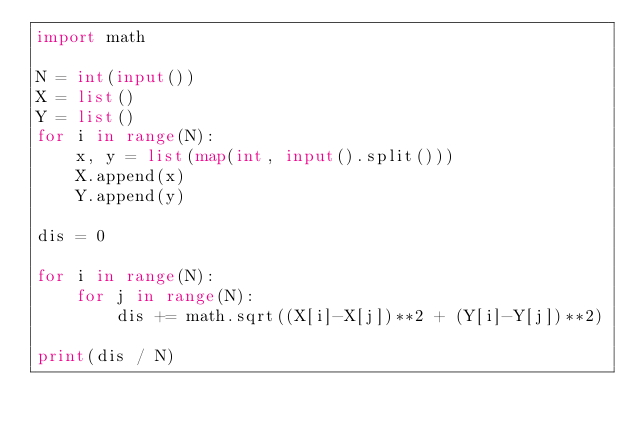Convert code to text. <code><loc_0><loc_0><loc_500><loc_500><_Python_>import math

N = int(input())
X = list()
Y = list()
for i in range(N):
    x, y = list(map(int, input().split()))
    X.append(x)
    Y.append(y)

dis = 0

for i in range(N):
    for j in range(N):
        dis += math.sqrt((X[i]-X[j])**2 + (Y[i]-Y[j])**2)

print(dis / N)
</code> 